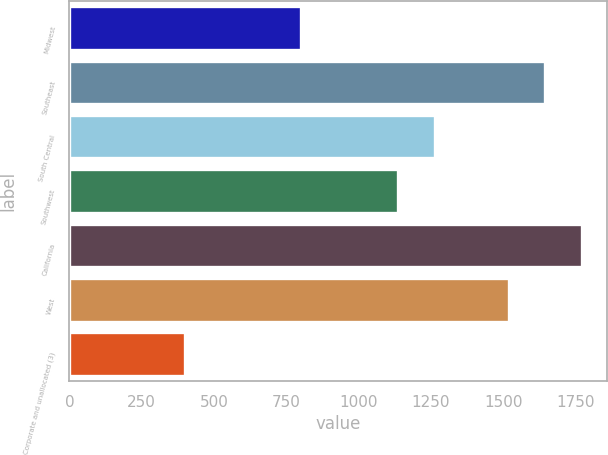<chart> <loc_0><loc_0><loc_500><loc_500><bar_chart><fcel>Midwest<fcel>Southeast<fcel>South Central<fcel>Southwest<fcel>California<fcel>West<fcel>Corporate and unallocated (3)<nl><fcel>801.3<fcel>1646.22<fcel>1263.02<fcel>1136.7<fcel>1772.54<fcel>1519.9<fcel>398.5<nl></chart> 